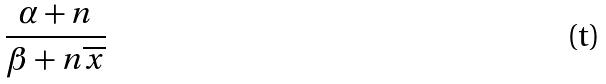Convert formula to latex. <formula><loc_0><loc_0><loc_500><loc_500>\frac { \alpha + n } { \beta + n \overline { x } }</formula> 